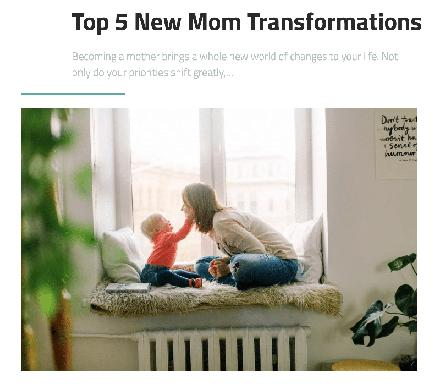What does the text say about priorities after becoming a mother? According to the text, a significant transformation after becoming a mother is a noticeable shift in priorities. New mothers often find their previous commitments and interests taking a back seat as their newborn's needs and well-being become paramount, illustrating a deep, instinctive recalibration of what they value most. 